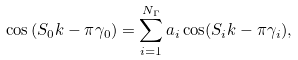Convert formula to latex. <formula><loc_0><loc_0><loc_500><loc_500>\cos \left ( S _ { 0 } k - \pi \gamma _ { 0 } \right ) = \sum _ { i = 1 } ^ { N _ { \Gamma } } a _ { i } \cos ( S _ { i } k - \pi \gamma _ { i } ) ,</formula> 